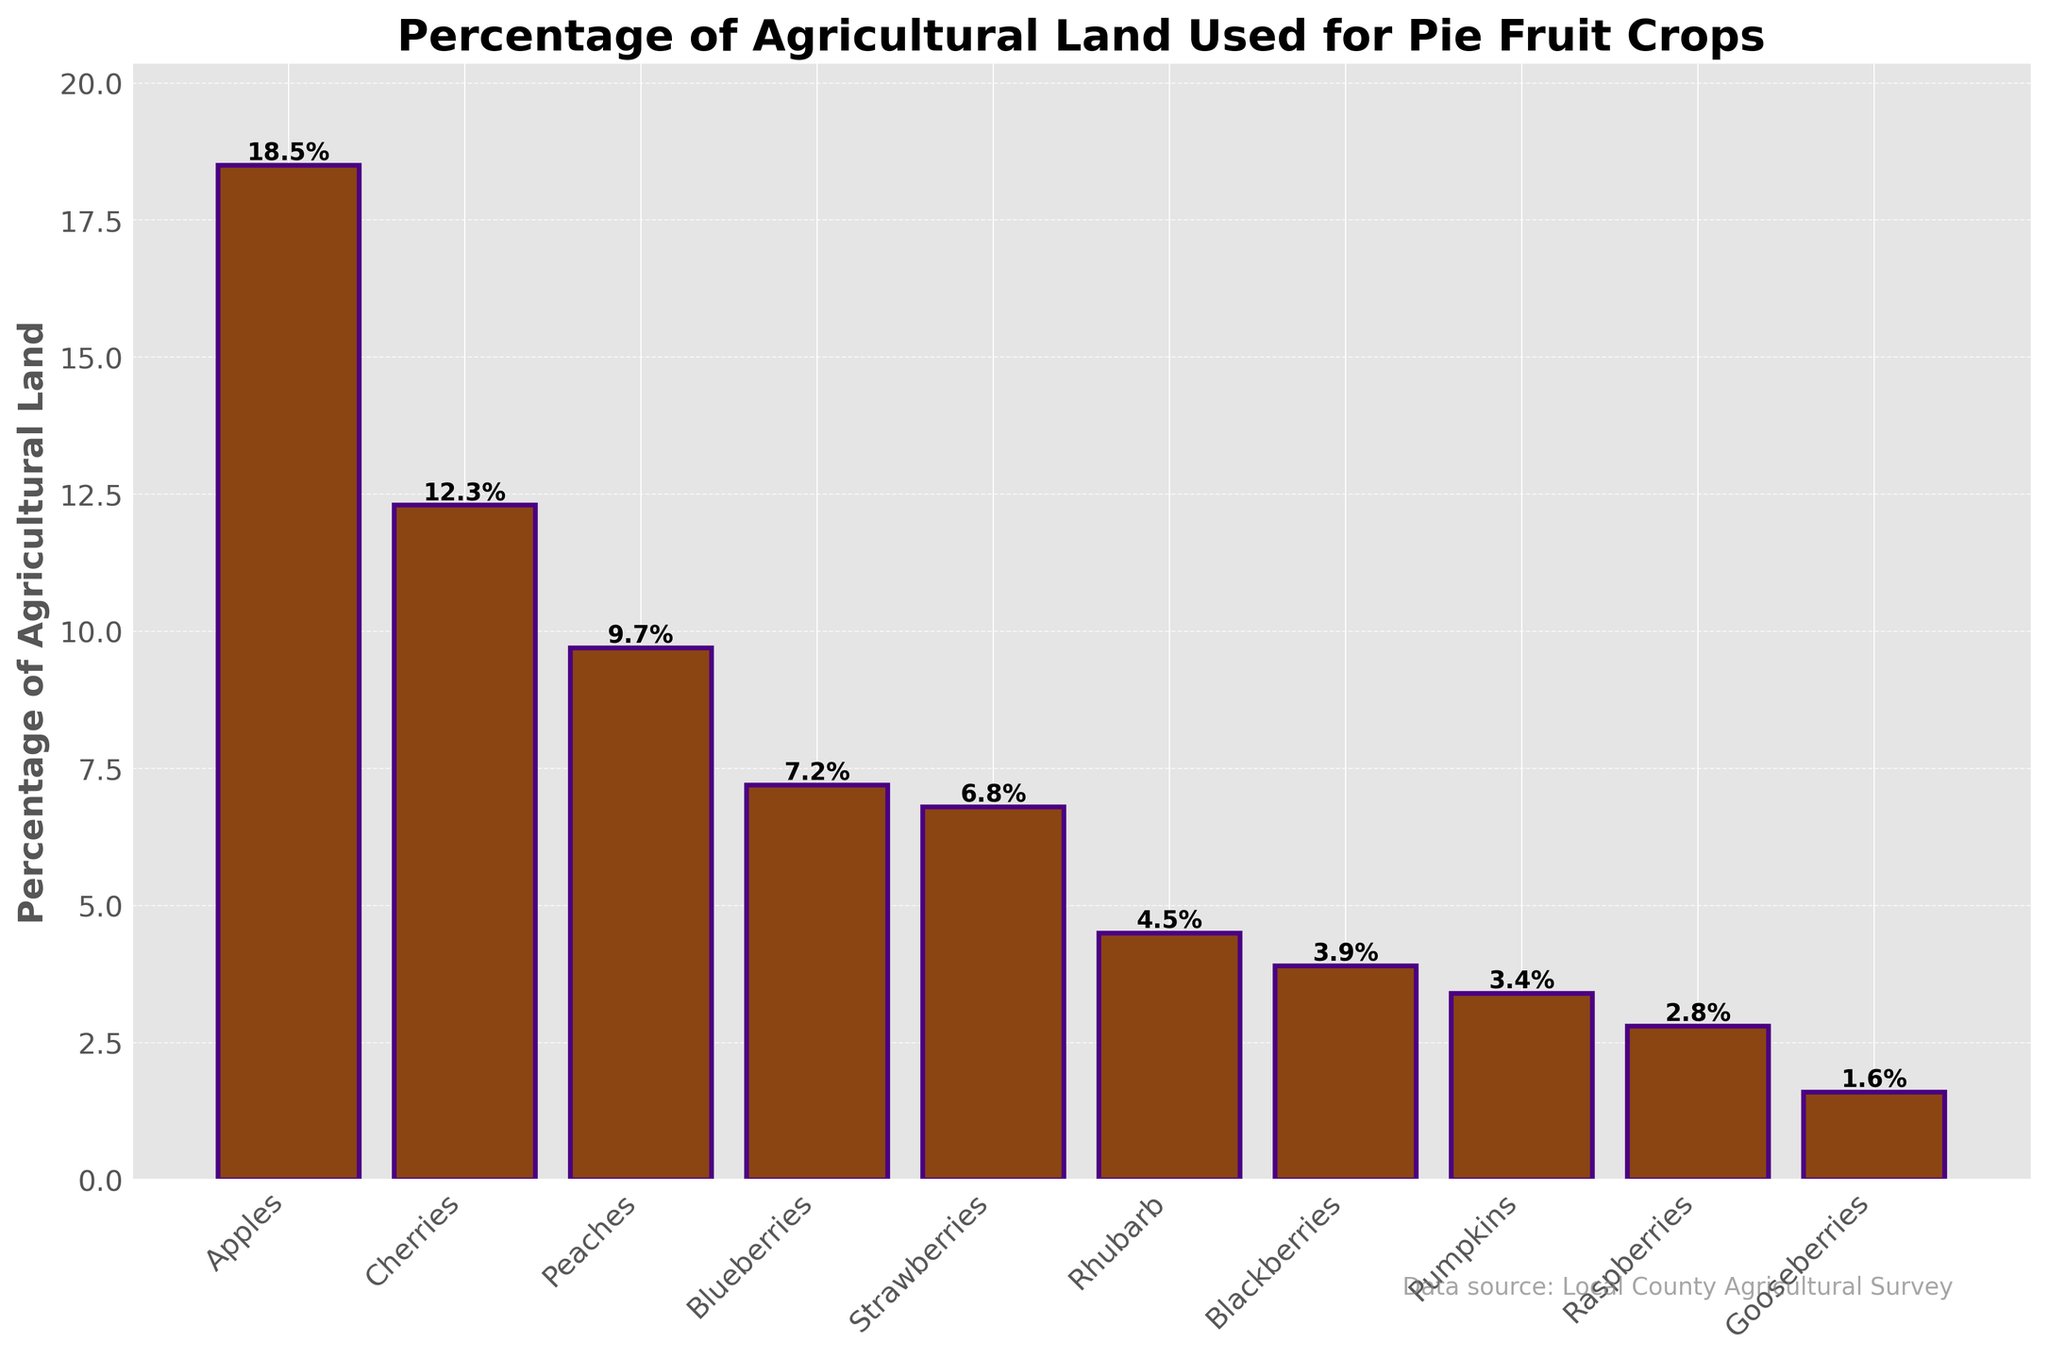Which crop takes up the largest percentage of agricultural land? The tallest bar represents the crop taking up the largest percentage. In this case, it's the bar for Apples.
Answer: Apples What is the combined percentage of agricultural land used for Apples and Cherries? Add the percentages of the bars for Apples and Cherries. Apples: 18.5%, Cherries: 12.3%. Combined: 18.5 + 12.3 = 30.8
Answer: 30.8 Which two crops use the smallest percentage of agricultural land? Identify the two shortest bars, which correspond to the smallest percentages. These are the bars for Gooseberries and Raspberries.
Answer: Gooseberries and Raspberries Are Peaches grown on more or less land than Blueberries? Compare the heights of the bars for Peaches and Blueberries. The bar for Peaches is higher than the bar for Blueberries.
Answer: More What is the difference in the percentage of agricultural land used between Rhubarb and Blackberries? Subtract the percentage for Blackberries from that for Rhubarb. Rhubarb: 4.5%, Blackberries: 3.9%. Difference: 4.5 - 3.9 = 0.6
Answer: 0.6 What is the average percentage of agricultural land used for Strawberries, Blueberries, and Raspberries? Add the percentages for Strawberries, Blueberries, and Raspberries and divide by 3. Strawberries: 6.8%, Blueberries: 7.2%, Raspberries: 2.8%. Sum: 6.8 + 7.2 + 2.8 = 16.8; Average: 16.8 / 3 ≈ 5.6
Answer: 5.6 Which crop represents just over 4% of agricultural land use? Look for the bar slightly over the 4% mark. The closest is Rhubarb.
Answer: Rhubarb Is any single crop responsible for more than 20% of the agricultural land use? Examine the bar heights and percentages. No bar reaches or exceeds 20%.
Answer: No What is the total percentage of agricultural land used for growing Blackberries, Pumpkins, and Raspberries? Add the percentages of the bars for Blackberries, Pumpkins, and Raspberries. Blackberries: 3.9%, Pumpkins: 3.4%, Raspberries: 2.8%. Total: 3.9 + 3.4 + 2.8 = 10.1
Answer: 10.1 